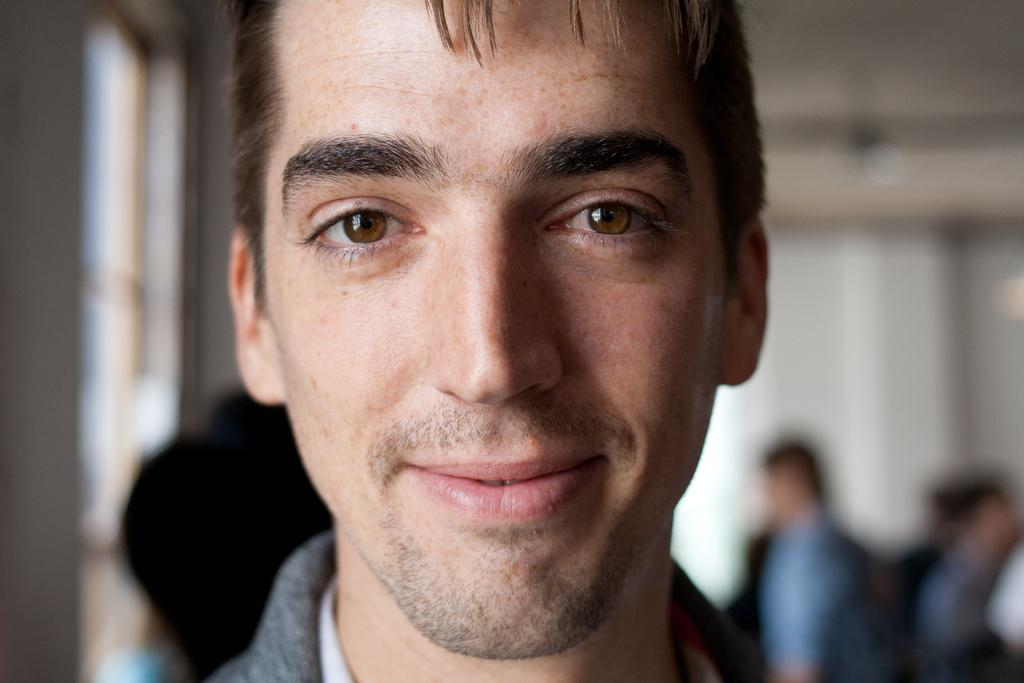Who is present in the image? There is a man in the picture. What is the man doing in the image? The man is smiling. What can be seen in the background of the image? There are people standing near a wall in the background, and there is a window beside the wall. What type of design can be seen on the man's shirt in the image? There is no information about the man's shirt in the provided facts, so we cannot determine the design. What drink is the man holding in the image? There is no drink visible in the image. 